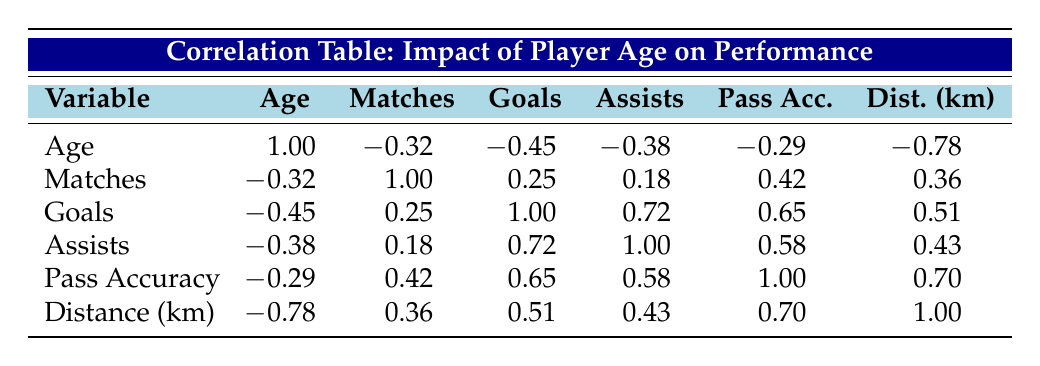What is the correlation between player age and goals scored? The table shows a correlation value of -0.45 between age and goals. This indicates a negative relationship, suggesting that as player age increases, the number of goals scored tends to decrease.
Answer: -0.45 Is there a positive correlation between assists and matches played? The table indicates a correlation of 0.18 between assists and matches played, which is positive but relatively weak. This implies that greater participation in matches does slightly correlate with more assists.
Answer: Yes Which metric has the strongest negative correlation with age? The strongest negative correlation with age is seen in distance covered (km), which has a correlation value of -0.78. This suggests that as players age, the distance they cover in matches tends to decrease significantly.
Answer: -0.78 What is the average number of goals scored by players aged 30 and above? Players aged 30 and above are Michael Brown (5 goals), David Martinez (4 goals), and Jessica Kim (6 goals). Summing these gives 5 + 4 + 6 = 15 goals. There are 3 players, so the average is 15/3 = 5.
Answer: 5 Is it true that younger players (age 21 and under) have a higher average pass accuracy than older players (age 30 and above)? For younger players, Sarah Lopez has a pass accuracy of 84 and Brian Lee has 83, averaging 83.5. For older players, Michael Brown has 79, David Martinez has 75, and Jessica Kim has 80, averaging 78. So, younger players have a higher average pass accuracy.
Answer: Yes How much does the distance covered change on average for every year decrease in player age? The correlation between age and distance covered is -0.78, indicating an average decrease in distance covered by approximately 0.78 km for each year of age increase.
Answer: 0.78 km What is the total number of assists from players aged 29 or younger? The players aged 29 or younger are James Smith (5 assists), Emily Davis (6 assists), Sarah Lopez (7 assists), and Brian Lee (2 assists). Summing these gives 5 + 6 + 7 + 2 = 20 assists.
Answer: 20 What is the correlation between matches played and pass accuracy? The correlation between matches played and pass accuracy is 0.42. This positive value indicates that as the number of matches played increases, the pass accuracy tends to increase as well.
Answer: 0.42 